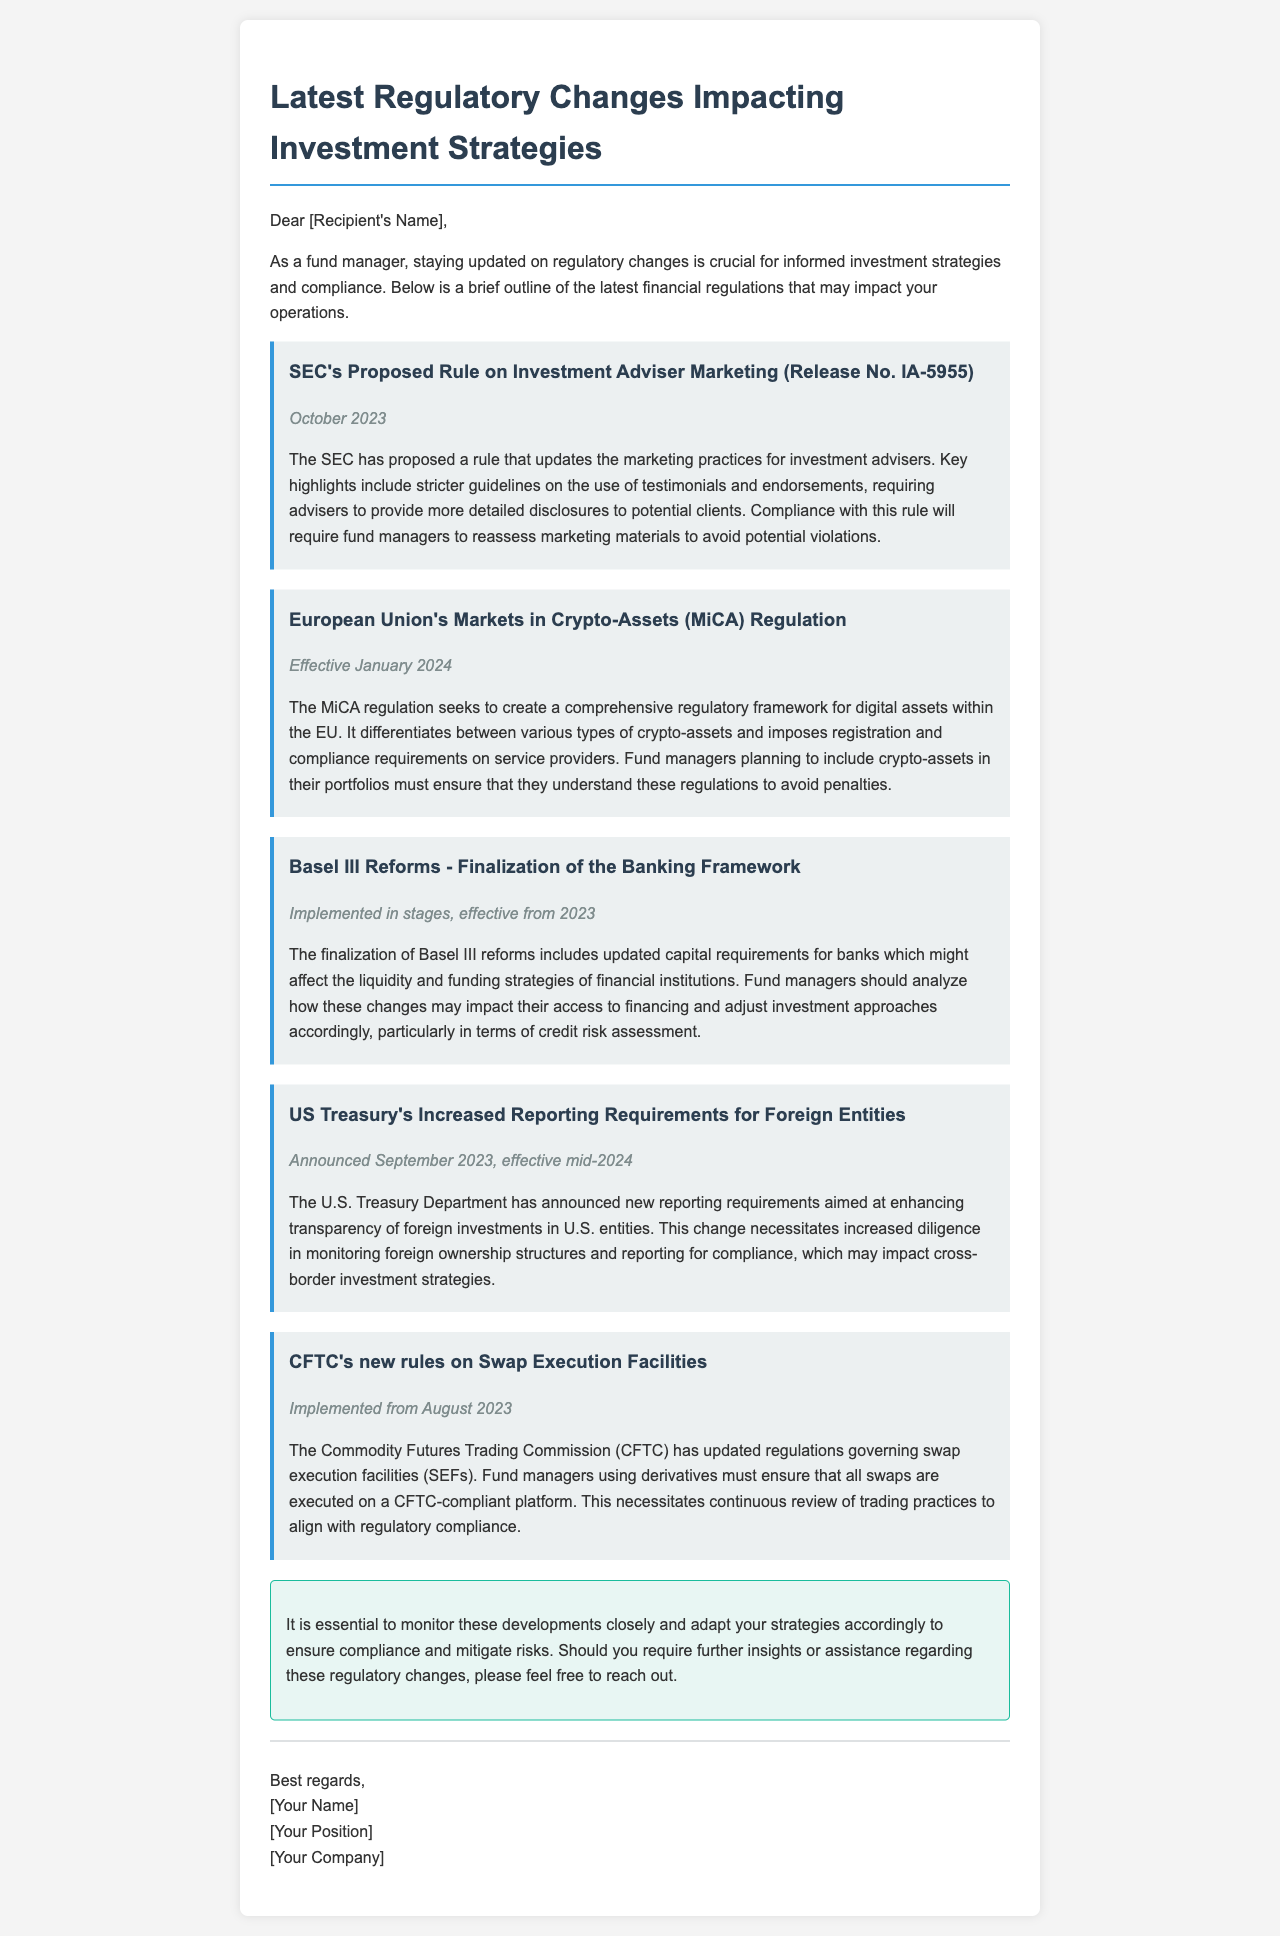What is the title of the email? The title is prominently displayed at the top of the email, denoting its focus area.
Answer: Latest Regulatory Changes Impacting Investment Strategies What is the date of the SEC's proposed rule on investment adviser marketing? The date is mentioned right below the title of that specific regulation in the email.
Answer: October 2023 When is the MiCA regulation effective? The effective date of the MiCA regulation is specified within its description.
Answer: January 2024 What is the significance of Basel III reforms as per the document? The significance is explicitly stated in relation to capital requirements and its implications for financial strategies.
Answer: Updated capital requirements What new reporting requirement was announced by the US Treasury? The document highlights increased reporting requirements aimed at transparency.
Answer: Increased reporting requirements for foreign entities Which organization updated rules governing swap execution facilities? The document explicitly names the organization responsible for the updates in this regulation.
Answer: CFTC What is a key requirement for fund managers regarding crypto-assets? The necessity for understanding specific regulations is a critical takeaway from the MiCA section.
Answer: Compliance requirements What is the document asking fund managers to do with respect to the new regulations? The conclusion section explicitly urges fund managers to take certain actions based on the regulatory changes.
Answer: Monitor developments closely What type of document is this? This document is structured in a manner typical for communications aimed at providing updates or briefings.
Answer: Email 